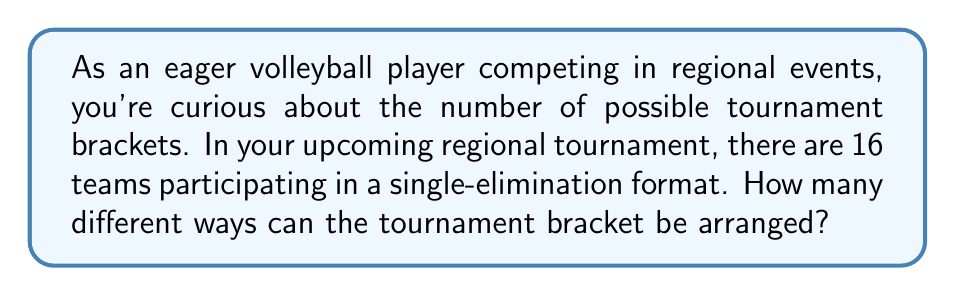Help me with this question. Let's approach this step-by-step:

1) In a single-elimination tournament with 16 teams, there are 4 rounds:
   - Round 1: 8 matches (16 teams)
   - Round 2 (Quarter-finals): 4 matches (8 teams)
   - Round 3 (Semi-finals): 2 matches (4 teams)
   - Round 4 (Final): 1 match (2 teams)

2) The number of possible arrangements for each round can be calculated as follows:

   Round 1: There are 16 teams to be paired into 8 matches. This can be done in:
   $$ \frac{16!}{(2!)^8 \cdot 8!} $$
   ways.

3) For each subsequent round, the teams are already determined by the winners of the previous round, so there's only one way to arrange each of these rounds.

4) Therefore, the total number of possible tournament brackets is equal to the number of ways to arrange the first round.

5) Let's calculate this:
   $$ \frac{16!}{(2!)^8 \cdot 8!} = \frac{16 \cdot 15 \cdot 14 \cdot 13 \cdot 12 \cdot 11 \cdot 10 \cdot 9}{(2 \cdot 2 \cdot 2 \cdot 2 \cdot 2 \cdot 2 \cdot 2 \cdot 2)} $$

6) Simplifying:
   $$ = \frac{16 \cdot 15 \cdot 7 \cdot 13 \cdot 3 \cdot 11 \cdot 5 \cdot 9}{2^8} = \frac{2,027,025}{256} = 7,918.0625 $$

7) Since we can't have a fractional number of brackets, we round down to the nearest whole number.
Answer: There are 7,918 different ways the tournament bracket can be arranged. 